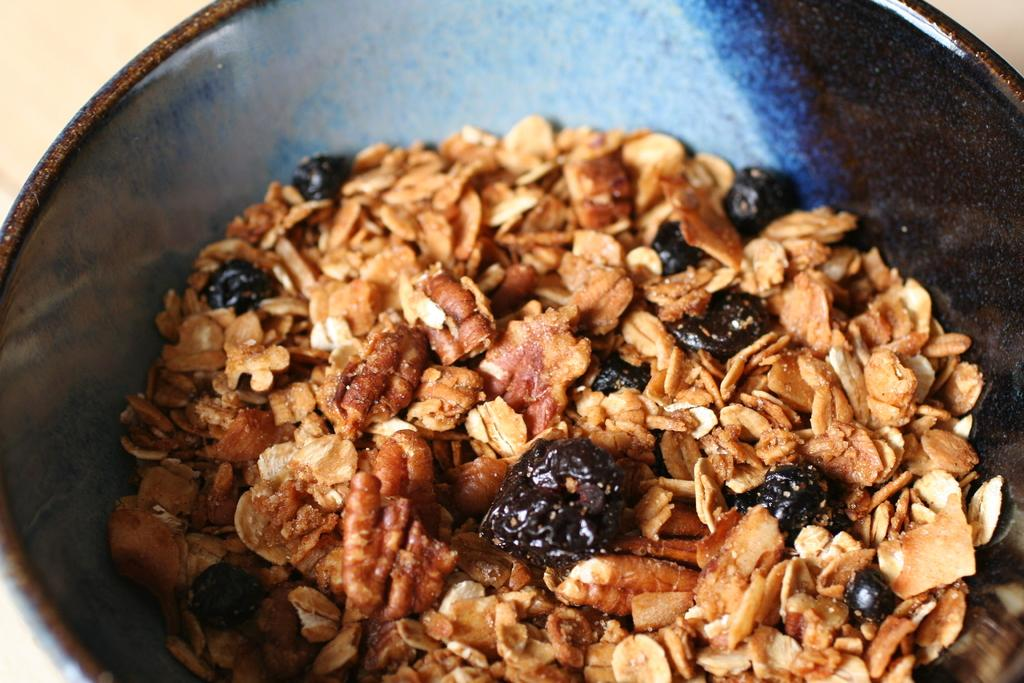What is the main subject of the image? There is a food item in the image. How is the food item contained or presented? The food item is in a black color vessel. Where is the black color vessel located? The black color vessel is on a surface. Reasoning: Let'g: Let's think step by step in order to produce the conversation. We start by identifying the main subject of the image, which is the food item. Then, we describe the container or presentation of the food item, which is a black color vessel. Finally, we mention the location of the vessel, which is on a surface. Absurd Question/Answer: What type of shock can be seen in the image? There is no shock present in the image. Is the food item being prepared in the wilderness? The provided facts do not mention the location or setting of the image, so it cannot be determined if it is in the wilderness. Is there a secretary working in the image? There is no mention of a secretary or any office-related elements in the image. 